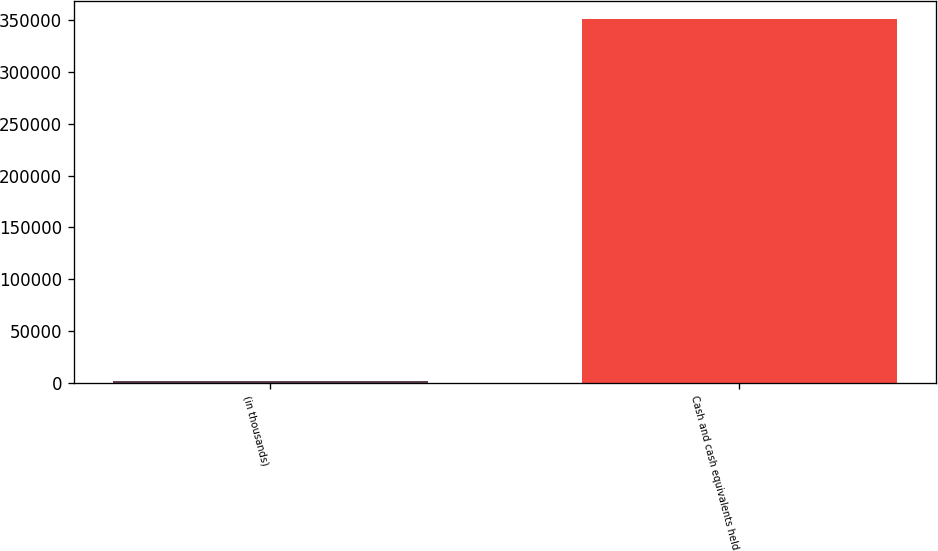<chart> <loc_0><loc_0><loc_500><loc_500><bar_chart><fcel>(in thousands)<fcel>Cash and cash equivalents held<nl><fcel>2014<fcel>350628<nl></chart> 